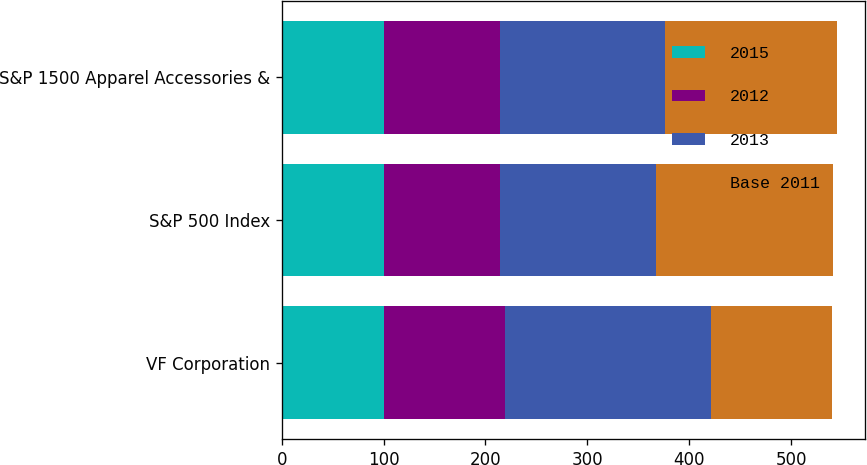Convert chart. <chart><loc_0><loc_0><loc_500><loc_500><stacked_bar_chart><ecel><fcel>VF Corporation<fcel>S&P 500 Index<fcel>S&P 1500 Apparel Accessories &<nl><fcel>2015<fcel>100<fcel>100<fcel>100<nl><fcel>2012<fcel>119.19<fcel>114.07<fcel>114.77<nl><fcel>2013<fcel>201.79<fcel>152.98<fcel>161.05<nl><fcel>Base 2011<fcel>119.19<fcel>174.56<fcel>169.73<nl></chart> 